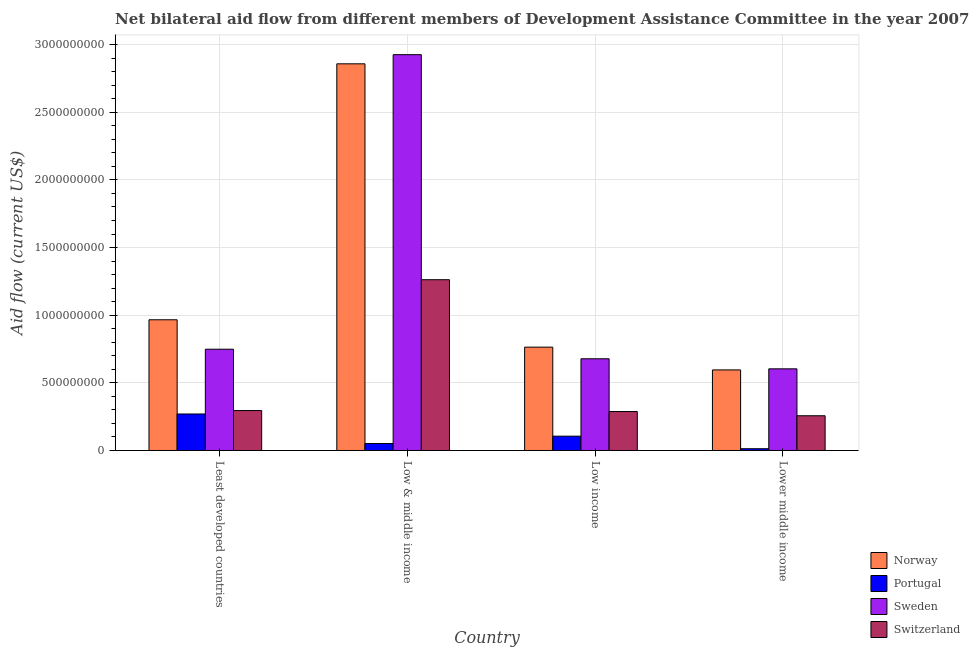Are the number of bars per tick equal to the number of legend labels?
Your answer should be very brief. Yes. What is the amount of aid given by switzerland in Lower middle income?
Ensure brevity in your answer.  2.57e+08. Across all countries, what is the maximum amount of aid given by sweden?
Offer a very short reply. 2.93e+09. Across all countries, what is the minimum amount of aid given by norway?
Your answer should be compact. 5.96e+08. In which country was the amount of aid given by switzerland maximum?
Provide a short and direct response. Low & middle income. In which country was the amount of aid given by portugal minimum?
Offer a terse response. Lower middle income. What is the total amount of aid given by sweden in the graph?
Offer a very short reply. 4.96e+09. What is the difference between the amount of aid given by sweden in Least developed countries and that in Low income?
Offer a terse response. 7.07e+07. What is the difference between the amount of aid given by sweden in Lower middle income and the amount of aid given by switzerland in Low & middle income?
Your answer should be compact. -6.59e+08. What is the average amount of aid given by sweden per country?
Keep it short and to the point. 1.24e+09. What is the difference between the amount of aid given by sweden and amount of aid given by switzerland in Low income?
Offer a terse response. 3.90e+08. In how many countries, is the amount of aid given by norway greater than 200000000 US$?
Ensure brevity in your answer.  4. What is the ratio of the amount of aid given by sweden in Least developed countries to that in Low & middle income?
Make the answer very short. 0.26. Is the difference between the amount of aid given by switzerland in Low & middle income and Lower middle income greater than the difference between the amount of aid given by portugal in Low & middle income and Lower middle income?
Give a very brief answer. Yes. What is the difference between the highest and the second highest amount of aid given by switzerland?
Offer a very short reply. 9.67e+08. What is the difference between the highest and the lowest amount of aid given by sweden?
Your response must be concise. 2.32e+09. Is the sum of the amount of aid given by norway in Least developed countries and Low & middle income greater than the maximum amount of aid given by sweden across all countries?
Provide a succinct answer. Yes. Is it the case that in every country, the sum of the amount of aid given by sweden and amount of aid given by switzerland is greater than the sum of amount of aid given by norway and amount of aid given by portugal?
Keep it short and to the point. Yes. What does the 4th bar from the left in Low & middle income represents?
Make the answer very short. Switzerland. How many bars are there?
Offer a very short reply. 16. Does the graph contain any zero values?
Make the answer very short. No. Does the graph contain grids?
Give a very brief answer. Yes. How many legend labels are there?
Give a very brief answer. 4. What is the title of the graph?
Give a very brief answer. Net bilateral aid flow from different members of Development Assistance Committee in the year 2007. Does "Environmental sustainability" appear as one of the legend labels in the graph?
Your response must be concise. No. What is the label or title of the X-axis?
Provide a short and direct response. Country. What is the Aid flow (current US$) of Norway in Least developed countries?
Offer a terse response. 9.66e+08. What is the Aid flow (current US$) of Portugal in Least developed countries?
Provide a short and direct response. 2.70e+08. What is the Aid flow (current US$) in Sweden in Least developed countries?
Your answer should be compact. 7.48e+08. What is the Aid flow (current US$) in Switzerland in Least developed countries?
Ensure brevity in your answer.  2.95e+08. What is the Aid flow (current US$) of Norway in Low & middle income?
Provide a short and direct response. 2.86e+09. What is the Aid flow (current US$) in Portugal in Low & middle income?
Offer a terse response. 5.16e+07. What is the Aid flow (current US$) in Sweden in Low & middle income?
Keep it short and to the point. 2.93e+09. What is the Aid flow (current US$) of Switzerland in Low & middle income?
Keep it short and to the point. 1.26e+09. What is the Aid flow (current US$) of Norway in Low income?
Make the answer very short. 7.64e+08. What is the Aid flow (current US$) in Portugal in Low income?
Ensure brevity in your answer.  1.06e+08. What is the Aid flow (current US$) in Sweden in Low income?
Offer a terse response. 6.78e+08. What is the Aid flow (current US$) of Switzerland in Low income?
Your answer should be very brief. 2.88e+08. What is the Aid flow (current US$) in Norway in Lower middle income?
Provide a succinct answer. 5.96e+08. What is the Aid flow (current US$) of Portugal in Lower middle income?
Ensure brevity in your answer.  1.30e+07. What is the Aid flow (current US$) of Sweden in Lower middle income?
Offer a very short reply. 6.04e+08. What is the Aid flow (current US$) of Switzerland in Lower middle income?
Ensure brevity in your answer.  2.57e+08. Across all countries, what is the maximum Aid flow (current US$) in Norway?
Your answer should be very brief. 2.86e+09. Across all countries, what is the maximum Aid flow (current US$) in Portugal?
Offer a terse response. 2.70e+08. Across all countries, what is the maximum Aid flow (current US$) in Sweden?
Offer a terse response. 2.93e+09. Across all countries, what is the maximum Aid flow (current US$) of Switzerland?
Keep it short and to the point. 1.26e+09. Across all countries, what is the minimum Aid flow (current US$) of Norway?
Offer a very short reply. 5.96e+08. Across all countries, what is the minimum Aid flow (current US$) of Portugal?
Provide a short and direct response. 1.30e+07. Across all countries, what is the minimum Aid flow (current US$) in Sweden?
Provide a short and direct response. 6.04e+08. Across all countries, what is the minimum Aid flow (current US$) in Switzerland?
Your answer should be compact. 2.57e+08. What is the total Aid flow (current US$) in Norway in the graph?
Keep it short and to the point. 5.18e+09. What is the total Aid flow (current US$) of Portugal in the graph?
Ensure brevity in your answer.  4.40e+08. What is the total Aid flow (current US$) in Sweden in the graph?
Your response must be concise. 4.96e+09. What is the total Aid flow (current US$) of Switzerland in the graph?
Give a very brief answer. 2.10e+09. What is the difference between the Aid flow (current US$) of Norway in Least developed countries and that in Low & middle income?
Your answer should be very brief. -1.89e+09. What is the difference between the Aid flow (current US$) of Portugal in Least developed countries and that in Low & middle income?
Ensure brevity in your answer.  2.18e+08. What is the difference between the Aid flow (current US$) of Sweden in Least developed countries and that in Low & middle income?
Your response must be concise. -2.18e+09. What is the difference between the Aid flow (current US$) of Switzerland in Least developed countries and that in Low & middle income?
Provide a short and direct response. -9.67e+08. What is the difference between the Aid flow (current US$) of Norway in Least developed countries and that in Low income?
Your answer should be compact. 2.02e+08. What is the difference between the Aid flow (current US$) in Portugal in Least developed countries and that in Low income?
Your response must be concise. 1.64e+08. What is the difference between the Aid flow (current US$) of Sweden in Least developed countries and that in Low income?
Provide a short and direct response. 7.07e+07. What is the difference between the Aid flow (current US$) of Switzerland in Least developed countries and that in Low income?
Give a very brief answer. 7.29e+06. What is the difference between the Aid flow (current US$) of Norway in Least developed countries and that in Lower middle income?
Offer a very short reply. 3.71e+08. What is the difference between the Aid flow (current US$) in Portugal in Least developed countries and that in Lower middle income?
Your answer should be very brief. 2.57e+08. What is the difference between the Aid flow (current US$) of Sweden in Least developed countries and that in Lower middle income?
Provide a short and direct response. 1.45e+08. What is the difference between the Aid flow (current US$) in Switzerland in Least developed countries and that in Lower middle income?
Provide a succinct answer. 3.85e+07. What is the difference between the Aid flow (current US$) in Norway in Low & middle income and that in Low income?
Provide a succinct answer. 2.09e+09. What is the difference between the Aid flow (current US$) in Portugal in Low & middle income and that in Low income?
Your response must be concise. -5.42e+07. What is the difference between the Aid flow (current US$) in Sweden in Low & middle income and that in Low income?
Your answer should be compact. 2.25e+09. What is the difference between the Aid flow (current US$) of Switzerland in Low & middle income and that in Low income?
Provide a short and direct response. 9.74e+08. What is the difference between the Aid flow (current US$) in Norway in Low & middle income and that in Lower middle income?
Provide a succinct answer. 2.26e+09. What is the difference between the Aid flow (current US$) in Portugal in Low & middle income and that in Lower middle income?
Offer a terse response. 3.86e+07. What is the difference between the Aid flow (current US$) in Sweden in Low & middle income and that in Lower middle income?
Keep it short and to the point. 2.32e+09. What is the difference between the Aid flow (current US$) of Switzerland in Low & middle income and that in Lower middle income?
Offer a very short reply. 1.01e+09. What is the difference between the Aid flow (current US$) in Norway in Low income and that in Lower middle income?
Offer a very short reply. 1.68e+08. What is the difference between the Aid flow (current US$) of Portugal in Low income and that in Lower middle income?
Your answer should be compact. 9.28e+07. What is the difference between the Aid flow (current US$) in Sweden in Low income and that in Lower middle income?
Keep it short and to the point. 7.43e+07. What is the difference between the Aid flow (current US$) in Switzerland in Low income and that in Lower middle income?
Make the answer very short. 3.12e+07. What is the difference between the Aid flow (current US$) in Norway in Least developed countries and the Aid flow (current US$) in Portugal in Low & middle income?
Make the answer very short. 9.15e+08. What is the difference between the Aid flow (current US$) in Norway in Least developed countries and the Aid flow (current US$) in Sweden in Low & middle income?
Your response must be concise. -1.96e+09. What is the difference between the Aid flow (current US$) of Norway in Least developed countries and the Aid flow (current US$) of Switzerland in Low & middle income?
Your response must be concise. -2.96e+08. What is the difference between the Aid flow (current US$) in Portugal in Least developed countries and the Aid flow (current US$) in Sweden in Low & middle income?
Your answer should be very brief. -2.66e+09. What is the difference between the Aid flow (current US$) in Portugal in Least developed countries and the Aid flow (current US$) in Switzerland in Low & middle income?
Give a very brief answer. -9.92e+08. What is the difference between the Aid flow (current US$) of Sweden in Least developed countries and the Aid flow (current US$) of Switzerland in Low & middle income?
Provide a short and direct response. -5.14e+08. What is the difference between the Aid flow (current US$) of Norway in Least developed countries and the Aid flow (current US$) of Portugal in Low income?
Offer a very short reply. 8.60e+08. What is the difference between the Aid flow (current US$) of Norway in Least developed countries and the Aid flow (current US$) of Sweden in Low income?
Your answer should be compact. 2.88e+08. What is the difference between the Aid flow (current US$) of Norway in Least developed countries and the Aid flow (current US$) of Switzerland in Low income?
Keep it short and to the point. 6.78e+08. What is the difference between the Aid flow (current US$) of Portugal in Least developed countries and the Aid flow (current US$) of Sweden in Low income?
Provide a short and direct response. -4.08e+08. What is the difference between the Aid flow (current US$) in Portugal in Least developed countries and the Aid flow (current US$) in Switzerland in Low income?
Your answer should be compact. -1.80e+07. What is the difference between the Aid flow (current US$) in Sweden in Least developed countries and the Aid flow (current US$) in Switzerland in Low income?
Offer a terse response. 4.61e+08. What is the difference between the Aid flow (current US$) in Norway in Least developed countries and the Aid flow (current US$) in Portugal in Lower middle income?
Provide a succinct answer. 9.53e+08. What is the difference between the Aid flow (current US$) in Norway in Least developed countries and the Aid flow (current US$) in Sweden in Lower middle income?
Give a very brief answer. 3.63e+08. What is the difference between the Aid flow (current US$) of Norway in Least developed countries and the Aid flow (current US$) of Switzerland in Lower middle income?
Ensure brevity in your answer.  7.09e+08. What is the difference between the Aid flow (current US$) of Portugal in Least developed countries and the Aid flow (current US$) of Sweden in Lower middle income?
Your answer should be compact. -3.34e+08. What is the difference between the Aid flow (current US$) in Portugal in Least developed countries and the Aid flow (current US$) in Switzerland in Lower middle income?
Make the answer very short. 1.32e+07. What is the difference between the Aid flow (current US$) in Sweden in Least developed countries and the Aid flow (current US$) in Switzerland in Lower middle income?
Provide a succinct answer. 4.92e+08. What is the difference between the Aid flow (current US$) in Norway in Low & middle income and the Aid flow (current US$) in Portugal in Low income?
Ensure brevity in your answer.  2.75e+09. What is the difference between the Aid flow (current US$) of Norway in Low & middle income and the Aid flow (current US$) of Sweden in Low income?
Keep it short and to the point. 2.18e+09. What is the difference between the Aid flow (current US$) of Norway in Low & middle income and the Aid flow (current US$) of Switzerland in Low income?
Give a very brief answer. 2.57e+09. What is the difference between the Aid flow (current US$) of Portugal in Low & middle income and the Aid flow (current US$) of Sweden in Low income?
Provide a succinct answer. -6.26e+08. What is the difference between the Aid flow (current US$) in Portugal in Low & middle income and the Aid flow (current US$) in Switzerland in Low income?
Make the answer very short. -2.36e+08. What is the difference between the Aid flow (current US$) of Sweden in Low & middle income and the Aid flow (current US$) of Switzerland in Low income?
Ensure brevity in your answer.  2.64e+09. What is the difference between the Aid flow (current US$) in Norway in Low & middle income and the Aid flow (current US$) in Portugal in Lower middle income?
Your answer should be compact. 2.84e+09. What is the difference between the Aid flow (current US$) in Norway in Low & middle income and the Aid flow (current US$) in Sweden in Lower middle income?
Provide a succinct answer. 2.25e+09. What is the difference between the Aid flow (current US$) in Norway in Low & middle income and the Aid flow (current US$) in Switzerland in Lower middle income?
Give a very brief answer. 2.60e+09. What is the difference between the Aid flow (current US$) of Portugal in Low & middle income and the Aid flow (current US$) of Sweden in Lower middle income?
Offer a very short reply. -5.52e+08. What is the difference between the Aid flow (current US$) of Portugal in Low & middle income and the Aid flow (current US$) of Switzerland in Lower middle income?
Offer a terse response. -2.05e+08. What is the difference between the Aid flow (current US$) of Sweden in Low & middle income and the Aid flow (current US$) of Switzerland in Lower middle income?
Make the answer very short. 2.67e+09. What is the difference between the Aid flow (current US$) of Norway in Low income and the Aid flow (current US$) of Portugal in Lower middle income?
Your answer should be very brief. 7.51e+08. What is the difference between the Aid flow (current US$) of Norway in Low income and the Aid flow (current US$) of Sweden in Lower middle income?
Your answer should be compact. 1.60e+08. What is the difference between the Aid flow (current US$) in Norway in Low income and the Aid flow (current US$) in Switzerland in Lower middle income?
Your answer should be compact. 5.07e+08. What is the difference between the Aid flow (current US$) of Portugal in Low income and the Aid flow (current US$) of Sweden in Lower middle income?
Your answer should be compact. -4.98e+08. What is the difference between the Aid flow (current US$) of Portugal in Low income and the Aid flow (current US$) of Switzerland in Lower middle income?
Keep it short and to the point. -1.51e+08. What is the difference between the Aid flow (current US$) of Sweden in Low income and the Aid flow (current US$) of Switzerland in Lower middle income?
Make the answer very short. 4.21e+08. What is the average Aid flow (current US$) of Norway per country?
Your answer should be compact. 1.30e+09. What is the average Aid flow (current US$) in Portugal per country?
Make the answer very short. 1.10e+08. What is the average Aid flow (current US$) of Sweden per country?
Keep it short and to the point. 1.24e+09. What is the average Aid flow (current US$) of Switzerland per country?
Your response must be concise. 5.25e+08. What is the difference between the Aid flow (current US$) in Norway and Aid flow (current US$) in Portugal in Least developed countries?
Offer a very short reply. 6.96e+08. What is the difference between the Aid flow (current US$) of Norway and Aid flow (current US$) of Sweden in Least developed countries?
Your answer should be very brief. 2.18e+08. What is the difference between the Aid flow (current US$) in Norway and Aid flow (current US$) in Switzerland in Least developed countries?
Offer a very short reply. 6.71e+08. What is the difference between the Aid flow (current US$) of Portugal and Aid flow (current US$) of Sweden in Least developed countries?
Provide a succinct answer. -4.79e+08. What is the difference between the Aid flow (current US$) of Portugal and Aid flow (current US$) of Switzerland in Least developed countries?
Provide a short and direct response. -2.53e+07. What is the difference between the Aid flow (current US$) of Sweden and Aid flow (current US$) of Switzerland in Least developed countries?
Your answer should be very brief. 4.53e+08. What is the difference between the Aid flow (current US$) of Norway and Aid flow (current US$) of Portugal in Low & middle income?
Offer a terse response. 2.81e+09. What is the difference between the Aid flow (current US$) of Norway and Aid flow (current US$) of Sweden in Low & middle income?
Ensure brevity in your answer.  -6.77e+07. What is the difference between the Aid flow (current US$) in Norway and Aid flow (current US$) in Switzerland in Low & middle income?
Keep it short and to the point. 1.60e+09. What is the difference between the Aid flow (current US$) in Portugal and Aid flow (current US$) in Sweden in Low & middle income?
Give a very brief answer. -2.87e+09. What is the difference between the Aid flow (current US$) of Portugal and Aid flow (current US$) of Switzerland in Low & middle income?
Offer a very short reply. -1.21e+09. What is the difference between the Aid flow (current US$) of Sweden and Aid flow (current US$) of Switzerland in Low & middle income?
Make the answer very short. 1.66e+09. What is the difference between the Aid flow (current US$) of Norway and Aid flow (current US$) of Portugal in Low income?
Offer a very short reply. 6.58e+08. What is the difference between the Aid flow (current US$) in Norway and Aid flow (current US$) in Sweden in Low income?
Ensure brevity in your answer.  8.59e+07. What is the difference between the Aid flow (current US$) in Norway and Aid flow (current US$) in Switzerland in Low income?
Offer a terse response. 4.76e+08. What is the difference between the Aid flow (current US$) of Portugal and Aid flow (current US$) of Sweden in Low income?
Ensure brevity in your answer.  -5.72e+08. What is the difference between the Aid flow (current US$) of Portugal and Aid flow (current US$) of Switzerland in Low income?
Provide a short and direct response. -1.82e+08. What is the difference between the Aid flow (current US$) in Sweden and Aid flow (current US$) in Switzerland in Low income?
Keep it short and to the point. 3.90e+08. What is the difference between the Aid flow (current US$) in Norway and Aid flow (current US$) in Portugal in Lower middle income?
Provide a short and direct response. 5.83e+08. What is the difference between the Aid flow (current US$) of Norway and Aid flow (current US$) of Sweden in Lower middle income?
Give a very brief answer. -7.98e+06. What is the difference between the Aid flow (current US$) of Norway and Aid flow (current US$) of Switzerland in Lower middle income?
Ensure brevity in your answer.  3.39e+08. What is the difference between the Aid flow (current US$) in Portugal and Aid flow (current US$) in Sweden in Lower middle income?
Make the answer very short. -5.91e+08. What is the difference between the Aid flow (current US$) in Portugal and Aid flow (current US$) in Switzerland in Lower middle income?
Your answer should be compact. -2.44e+08. What is the difference between the Aid flow (current US$) in Sweden and Aid flow (current US$) in Switzerland in Lower middle income?
Your response must be concise. 3.47e+08. What is the ratio of the Aid flow (current US$) in Norway in Least developed countries to that in Low & middle income?
Provide a short and direct response. 0.34. What is the ratio of the Aid flow (current US$) in Portugal in Least developed countries to that in Low & middle income?
Give a very brief answer. 5.23. What is the ratio of the Aid flow (current US$) of Sweden in Least developed countries to that in Low & middle income?
Your answer should be compact. 0.26. What is the ratio of the Aid flow (current US$) in Switzerland in Least developed countries to that in Low & middle income?
Give a very brief answer. 0.23. What is the ratio of the Aid flow (current US$) in Norway in Least developed countries to that in Low income?
Offer a very short reply. 1.26. What is the ratio of the Aid flow (current US$) of Portugal in Least developed countries to that in Low income?
Your answer should be very brief. 2.55. What is the ratio of the Aid flow (current US$) of Sweden in Least developed countries to that in Low income?
Your answer should be very brief. 1.1. What is the ratio of the Aid flow (current US$) in Switzerland in Least developed countries to that in Low income?
Give a very brief answer. 1.03. What is the ratio of the Aid flow (current US$) in Norway in Least developed countries to that in Lower middle income?
Your response must be concise. 1.62. What is the ratio of the Aid flow (current US$) of Portugal in Least developed countries to that in Lower middle income?
Provide a succinct answer. 20.84. What is the ratio of the Aid flow (current US$) of Sweden in Least developed countries to that in Lower middle income?
Provide a short and direct response. 1.24. What is the ratio of the Aid flow (current US$) in Switzerland in Least developed countries to that in Lower middle income?
Give a very brief answer. 1.15. What is the ratio of the Aid flow (current US$) of Norway in Low & middle income to that in Low income?
Ensure brevity in your answer.  3.74. What is the ratio of the Aid flow (current US$) of Portugal in Low & middle income to that in Low income?
Your answer should be compact. 0.49. What is the ratio of the Aid flow (current US$) in Sweden in Low & middle income to that in Low income?
Offer a very short reply. 4.32. What is the ratio of the Aid flow (current US$) in Switzerland in Low & middle income to that in Low income?
Offer a very short reply. 4.38. What is the ratio of the Aid flow (current US$) in Norway in Low & middle income to that in Lower middle income?
Provide a succinct answer. 4.8. What is the ratio of the Aid flow (current US$) in Portugal in Low & middle income to that in Lower middle income?
Make the answer very short. 3.98. What is the ratio of the Aid flow (current US$) in Sweden in Low & middle income to that in Lower middle income?
Offer a terse response. 4.85. What is the ratio of the Aid flow (current US$) of Switzerland in Low & middle income to that in Lower middle income?
Make the answer very short. 4.92. What is the ratio of the Aid flow (current US$) of Norway in Low income to that in Lower middle income?
Ensure brevity in your answer.  1.28. What is the ratio of the Aid flow (current US$) in Portugal in Low income to that in Lower middle income?
Make the answer very short. 8.17. What is the ratio of the Aid flow (current US$) of Sweden in Low income to that in Lower middle income?
Provide a short and direct response. 1.12. What is the ratio of the Aid flow (current US$) of Switzerland in Low income to that in Lower middle income?
Keep it short and to the point. 1.12. What is the difference between the highest and the second highest Aid flow (current US$) in Norway?
Offer a very short reply. 1.89e+09. What is the difference between the highest and the second highest Aid flow (current US$) of Portugal?
Your answer should be compact. 1.64e+08. What is the difference between the highest and the second highest Aid flow (current US$) in Sweden?
Ensure brevity in your answer.  2.18e+09. What is the difference between the highest and the second highest Aid flow (current US$) of Switzerland?
Keep it short and to the point. 9.67e+08. What is the difference between the highest and the lowest Aid flow (current US$) in Norway?
Provide a short and direct response. 2.26e+09. What is the difference between the highest and the lowest Aid flow (current US$) of Portugal?
Make the answer very short. 2.57e+08. What is the difference between the highest and the lowest Aid flow (current US$) of Sweden?
Offer a very short reply. 2.32e+09. What is the difference between the highest and the lowest Aid flow (current US$) in Switzerland?
Your response must be concise. 1.01e+09. 